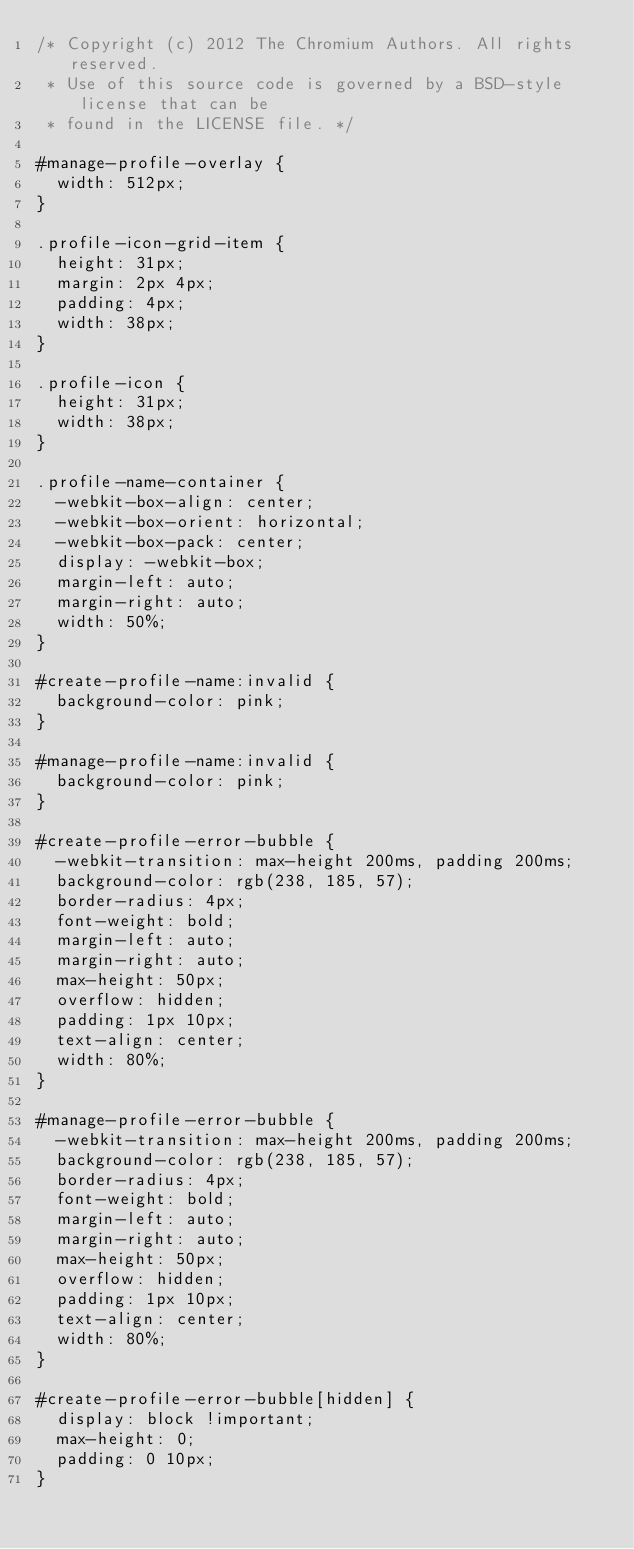<code> <loc_0><loc_0><loc_500><loc_500><_CSS_>/* Copyright (c) 2012 The Chromium Authors. All rights reserved.
 * Use of this source code is governed by a BSD-style license that can be
 * found in the LICENSE file. */

#manage-profile-overlay {
  width: 512px;
}

.profile-icon-grid-item {
  height: 31px;
  margin: 2px 4px;
  padding: 4px;
  width: 38px;
}

.profile-icon {
  height: 31px;
  width: 38px;
}

.profile-name-container {
  -webkit-box-align: center;
  -webkit-box-orient: horizontal;
  -webkit-box-pack: center;
  display: -webkit-box;
  margin-left: auto;
  margin-right: auto;
  width: 50%;
}

#create-profile-name:invalid {
  background-color: pink;
}

#manage-profile-name:invalid {
  background-color: pink;
}

#create-profile-error-bubble {
  -webkit-transition: max-height 200ms, padding 200ms;
  background-color: rgb(238, 185, 57);
  border-radius: 4px;
  font-weight: bold;
  margin-left: auto;
  margin-right: auto;
  max-height: 50px;
  overflow: hidden;
  padding: 1px 10px;
  text-align: center;
  width: 80%;
}

#manage-profile-error-bubble {
  -webkit-transition: max-height 200ms, padding 200ms;
  background-color: rgb(238, 185, 57);
  border-radius: 4px;
  font-weight: bold;
  margin-left: auto;
  margin-right: auto;
  max-height: 50px;
  overflow: hidden;
  padding: 1px 10px;
  text-align: center;
  width: 80%;
}

#create-profile-error-bubble[hidden] {
  display: block !important;
  max-height: 0;
  padding: 0 10px;
}
</code> 